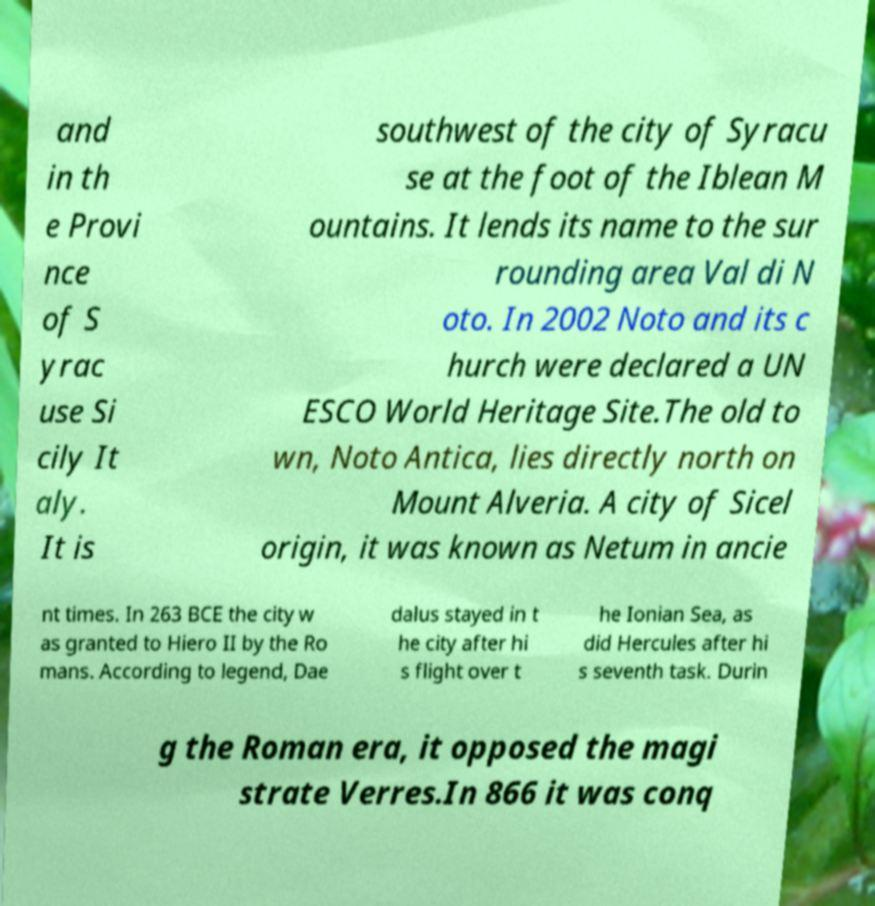There's text embedded in this image that I need extracted. Can you transcribe it verbatim? and in th e Provi nce of S yrac use Si cily It aly. It is southwest of the city of Syracu se at the foot of the Iblean M ountains. It lends its name to the sur rounding area Val di N oto. In 2002 Noto and its c hurch were declared a UN ESCO World Heritage Site.The old to wn, Noto Antica, lies directly north on Mount Alveria. A city of Sicel origin, it was known as Netum in ancie nt times. In 263 BCE the city w as granted to Hiero II by the Ro mans. According to legend, Dae dalus stayed in t he city after hi s flight over t he Ionian Sea, as did Hercules after hi s seventh task. Durin g the Roman era, it opposed the magi strate Verres.In 866 it was conq 